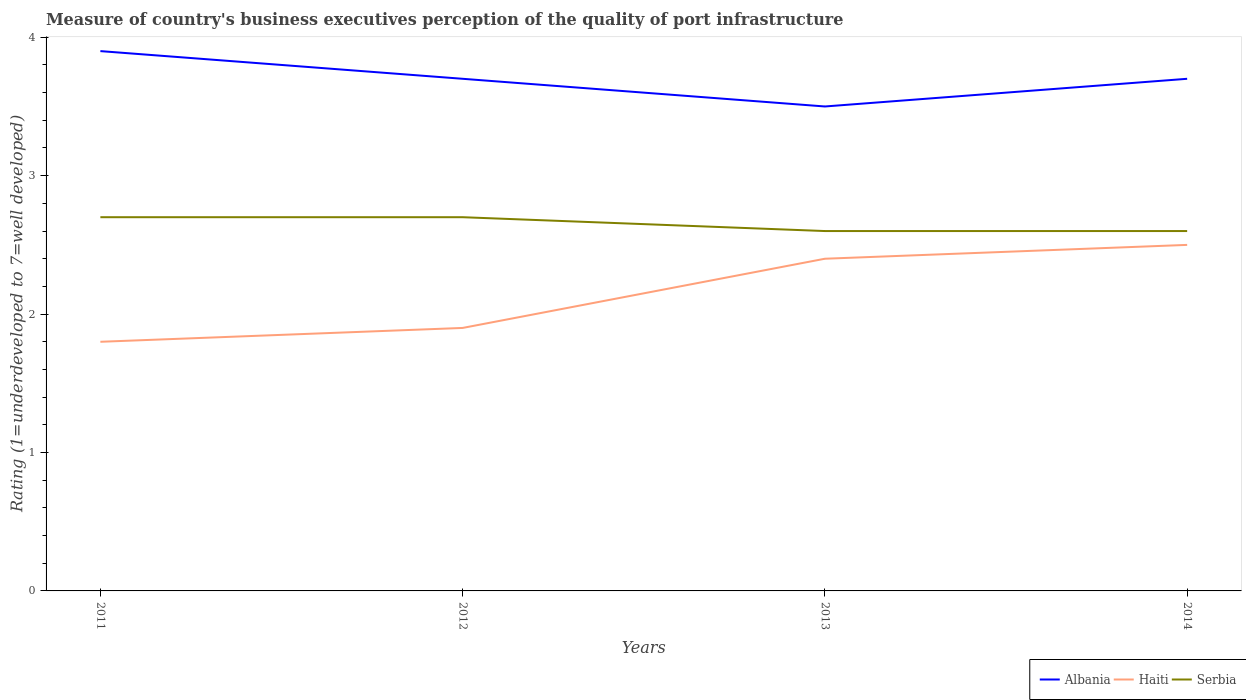Does the line corresponding to Haiti intersect with the line corresponding to Serbia?
Provide a short and direct response. No. In which year was the ratings of the quality of port infrastructure in Albania maximum?
Make the answer very short. 2013. What is the total ratings of the quality of port infrastructure in Haiti in the graph?
Your response must be concise. -0.6. What is the difference between the highest and the second highest ratings of the quality of port infrastructure in Albania?
Keep it short and to the point. 0.4. Is the ratings of the quality of port infrastructure in Albania strictly greater than the ratings of the quality of port infrastructure in Serbia over the years?
Offer a terse response. No. How many lines are there?
Your answer should be very brief. 3. How many years are there in the graph?
Your answer should be compact. 4. What is the difference between two consecutive major ticks on the Y-axis?
Offer a terse response. 1. Are the values on the major ticks of Y-axis written in scientific E-notation?
Your answer should be very brief. No. Does the graph contain any zero values?
Your response must be concise. No. Does the graph contain grids?
Your answer should be compact. No. What is the title of the graph?
Your answer should be very brief. Measure of country's business executives perception of the quality of port infrastructure. Does "Senegal" appear as one of the legend labels in the graph?
Ensure brevity in your answer.  No. What is the label or title of the X-axis?
Offer a terse response. Years. What is the label or title of the Y-axis?
Ensure brevity in your answer.  Rating (1=underdeveloped to 7=well developed). What is the Rating (1=underdeveloped to 7=well developed) of Haiti in 2012?
Your answer should be compact. 1.9. What is the Rating (1=underdeveloped to 7=well developed) in Serbia in 2012?
Your answer should be compact. 2.7. What is the Rating (1=underdeveloped to 7=well developed) of Albania in 2013?
Offer a terse response. 3.5. What is the Rating (1=underdeveloped to 7=well developed) of Haiti in 2014?
Provide a succinct answer. 2.5. What is the total Rating (1=underdeveloped to 7=well developed) of Albania in the graph?
Offer a terse response. 14.8. What is the difference between the Rating (1=underdeveloped to 7=well developed) in Albania in 2011 and that in 2012?
Your response must be concise. 0.2. What is the difference between the Rating (1=underdeveloped to 7=well developed) of Serbia in 2011 and that in 2012?
Give a very brief answer. 0. What is the difference between the Rating (1=underdeveloped to 7=well developed) of Albania in 2011 and that in 2013?
Your answer should be very brief. 0.4. What is the difference between the Rating (1=underdeveloped to 7=well developed) in Haiti in 2011 and that in 2013?
Give a very brief answer. -0.6. What is the difference between the Rating (1=underdeveloped to 7=well developed) in Serbia in 2011 and that in 2013?
Ensure brevity in your answer.  0.1. What is the difference between the Rating (1=underdeveloped to 7=well developed) of Albania in 2011 and that in 2014?
Provide a succinct answer. 0.2. What is the difference between the Rating (1=underdeveloped to 7=well developed) in Serbia in 2012 and that in 2013?
Ensure brevity in your answer.  0.1. What is the difference between the Rating (1=underdeveloped to 7=well developed) in Haiti in 2012 and that in 2014?
Your response must be concise. -0.6. What is the difference between the Rating (1=underdeveloped to 7=well developed) in Serbia in 2012 and that in 2014?
Provide a succinct answer. 0.1. What is the difference between the Rating (1=underdeveloped to 7=well developed) of Haiti in 2013 and that in 2014?
Keep it short and to the point. -0.1. What is the difference between the Rating (1=underdeveloped to 7=well developed) of Haiti in 2011 and the Rating (1=underdeveloped to 7=well developed) of Serbia in 2012?
Provide a succinct answer. -0.9. What is the difference between the Rating (1=underdeveloped to 7=well developed) of Haiti in 2011 and the Rating (1=underdeveloped to 7=well developed) of Serbia in 2013?
Make the answer very short. -0.8. What is the difference between the Rating (1=underdeveloped to 7=well developed) in Albania in 2011 and the Rating (1=underdeveloped to 7=well developed) in Haiti in 2014?
Your response must be concise. 1.4. What is the difference between the Rating (1=underdeveloped to 7=well developed) in Albania in 2012 and the Rating (1=underdeveloped to 7=well developed) in Haiti in 2013?
Offer a terse response. 1.3. What is the difference between the Rating (1=underdeveloped to 7=well developed) of Haiti in 2012 and the Rating (1=underdeveloped to 7=well developed) of Serbia in 2013?
Provide a succinct answer. -0.7. What is the difference between the Rating (1=underdeveloped to 7=well developed) in Albania in 2012 and the Rating (1=underdeveloped to 7=well developed) in Haiti in 2014?
Your answer should be very brief. 1.2. What is the difference between the Rating (1=underdeveloped to 7=well developed) of Albania in 2013 and the Rating (1=underdeveloped to 7=well developed) of Haiti in 2014?
Your response must be concise. 1. What is the average Rating (1=underdeveloped to 7=well developed) of Haiti per year?
Your response must be concise. 2.15. What is the average Rating (1=underdeveloped to 7=well developed) in Serbia per year?
Provide a short and direct response. 2.65. In the year 2013, what is the difference between the Rating (1=underdeveloped to 7=well developed) in Albania and Rating (1=underdeveloped to 7=well developed) in Serbia?
Provide a succinct answer. 0.9. In the year 2014, what is the difference between the Rating (1=underdeveloped to 7=well developed) of Haiti and Rating (1=underdeveloped to 7=well developed) of Serbia?
Offer a terse response. -0.1. What is the ratio of the Rating (1=underdeveloped to 7=well developed) of Albania in 2011 to that in 2012?
Keep it short and to the point. 1.05. What is the ratio of the Rating (1=underdeveloped to 7=well developed) in Haiti in 2011 to that in 2012?
Provide a succinct answer. 0.95. What is the ratio of the Rating (1=underdeveloped to 7=well developed) in Albania in 2011 to that in 2013?
Make the answer very short. 1.11. What is the ratio of the Rating (1=underdeveloped to 7=well developed) in Albania in 2011 to that in 2014?
Your answer should be very brief. 1.05. What is the ratio of the Rating (1=underdeveloped to 7=well developed) in Haiti in 2011 to that in 2014?
Provide a short and direct response. 0.72. What is the ratio of the Rating (1=underdeveloped to 7=well developed) of Serbia in 2011 to that in 2014?
Offer a terse response. 1.04. What is the ratio of the Rating (1=underdeveloped to 7=well developed) of Albania in 2012 to that in 2013?
Offer a very short reply. 1.06. What is the ratio of the Rating (1=underdeveloped to 7=well developed) in Haiti in 2012 to that in 2013?
Keep it short and to the point. 0.79. What is the ratio of the Rating (1=underdeveloped to 7=well developed) in Serbia in 2012 to that in 2013?
Offer a terse response. 1.04. What is the ratio of the Rating (1=underdeveloped to 7=well developed) of Haiti in 2012 to that in 2014?
Your answer should be compact. 0.76. What is the ratio of the Rating (1=underdeveloped to 7=well developed) of Serbia in 2012 to that in 2014?
Your answer should be very brief. 1.04. What is the ratio of the Rating (1=underdeveloped to 7=well developed) in Albania in 2013 to that in 2014?
Your response must be concise. 0.95. What is the ratio of the Rating (1=underdeveloped to 7=well developed) of Haiti in 2013 to that in 2014?
Provide a short and direct response. 0.96. What is the difference between the highest and the second highest Rating (1=underdeveloped to 7=well developed) in Haiti?
Your answer should be very brief. 0.1. What is the difference between the highest and the lowest Rating (1=underdeveloped to 7=well developed) in Albania?
Ensure brevity in your answer.  0.4. What is the difference between the highest and the lowest Rating (1=underdeveloped to 7=well developed) in Haiti?
Ensure brevity in your answer.  0.7. What is the difference between the highest and the lowest Rating (1=underdeveloped to 7=well developed) in Serbia?
Give a very brief answer. 0.1. 